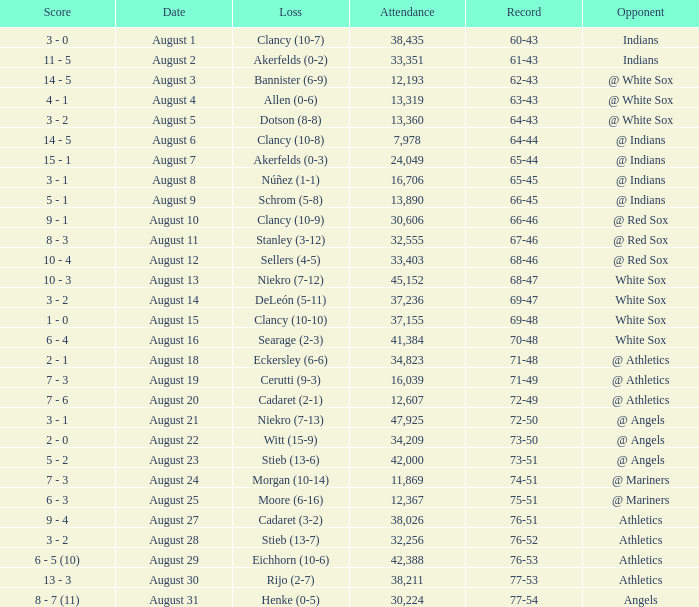What was the number of attendees when the record stood at 77-54? 30224.0. 